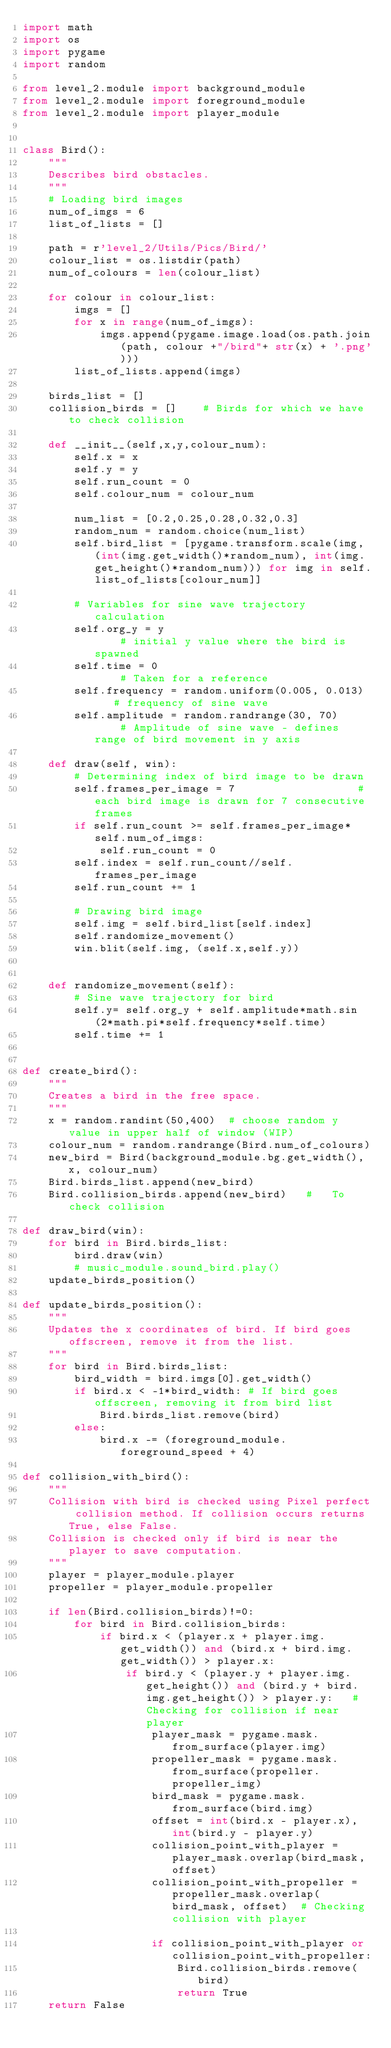Convert code to text. <code><loc_0><loc_0><loc_500><loc_500><_Python_>import math
import os
import pygame
import random

from level_2.module import background_module
from level_2.module import foreground_module
from level_2.module import player_module


class Bird():
	"""
	Describes bird obstacles.
	"""
	# Loading bird images
	num_of_imgs = 6
	list_of_lists = []

	path = r'level_2/Utils/Pics/Bird/'
	colour_list = os.listdir(path)
	num_of_colours = len(colour_list)	
	
	for colour in colour_list:
		imgs = []
		for x in range(num_of_imgs):
			imgs.append(pygame.image.load(os.path.join(path, colour +"/bird"+ str(x) + '.png')))
		list_of_lists.append(imgs)

	birds_list = []
	collision_birds = []	# Birds for which we have to check collision

	def __init__(self,x,y,colour_num):
		self.x = x
		self.y = y
		self.run_count = 0
		self.colour_num = colour_num

		num_list = [0.2,0.25,0.28,0.32,0.3]
		random_num = random.choice(num_list)
		self.bird_list = [pygame.transform.scale(img, (int(img.get_width()*random_num), int(img.get_height()*random_num))) for img in self.list_of_lists[colour_num]]

		# Variables for sine wave trajectory calculation
		self.org_y = y									# initial y value where the bird is spawned
		self.time = 0									# Taken for a reference
		self.frequency = random.uniform(0.005, 0.013)	# frequency of sine wave
		self.amplitude = random.randrange(30, 70)		# Amplitude of sine wave - defines range of bird movement in y axis

	def draw(self, win):
		# Determining index of bird image to be drawn
		self.frames_per_image = 7					# each bird image is drawn for 7 consecutive frames
		if self.run_count >= self.frames_per_image*self.num_of_imgs:
			self.run_count = 0
		self.index = self.run_count//self.frames_per_image
		self.run_count += 1
		
		# Drawing bird image
		self.img = self.bird_list[self.index]
		self.randomize_movement()
		win.blit(self.img, (self.x,self.y))
		

	def randomize_movement(self):
		# Sine wave trajectory for bird
		self.y= self.org_y + self.amplitude*math.sin(2*math.pi*self.frequency*self.time)
		self.time += 1


def create_bird():
	"""
	Creates a bird in the free space. 
	"""
	x = random.randint(50,400)	# choose random y value in upper half of window	(WIP)
	colour_num = random.randrange(Bird.num_of_colours)
	new_bird = Bird(background_module.bg.get_width(), x, colour_num)
	Bird.birds_list.append(new_bird)
	Bird.collision_birds.append(new_bird)	#	To check collision

def draw_bird(win):
	for bird in Bird.birds_list:
		bird.draw(win)
		# music_module.sound_bird.play()
	update_birds_position()
	
def update_birds_position():
	"""
	Updates the x coordinates of bird. If bird goes offscreen, remove it from the list.
	"""
	for bird in Bird.birds_list:
		bird_width = bird.imgs[0].get_width()
		if bird.x < -1*bird_width: # If bird goes offscreen, removing it from bird list 
			Bird.birds_list.remove(bird)
		else:
			bird.x -= (foreground_module.foreground_speed + 4)

def collision_with_bird():
	"""
	Collision with bird is checked using Pixel perfect collision method. If collision occurs returns True, else False.
	Collision is checked only if bird is near the player to save computation.
	"""
	player = player_module.player
	propeller = player_module.propeller

	if len(Bird.collision_birds)!=0:
		for bird in Bird.collision_birds:
			if bird.x < (player.x + player.img.get_width()) and (bird.x + bird.img.get_width()) > player.x:
				if bird.y < (player.y + player.img.get_height()) and (bird.y + bird.img.get_height()) > player.y:	# Checking for collision if near player
					player_mask = pygame.mask.from_surface(player.img)
					propeller_mask = pygame.mask.from_surface(propeller.propeller_img)
					bird_mask = pygame.mask.from_surface(bird.img)
					offset = int(bird.x - player.x), int(bird.y - player.y)
					collision_point_with_player = player_mask.overlap(bird_mask, offset)
					collision_point_with_propeller = propeller_mask.overlap(bird_mask, offset)	# Checking collision with player

					if collision_point_with_player or collision_point_with_propeller:
						Bird.collision_birds.remove(bird)
						return True
	return False</code> 